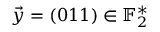Convert formula to latex. <formula><loc_0><loc_0><loc_500><loc_500>\vec { y } = ( 0 1 1 ) \in \mathbb { F } _ { 2 } ^ { * }</formula> 